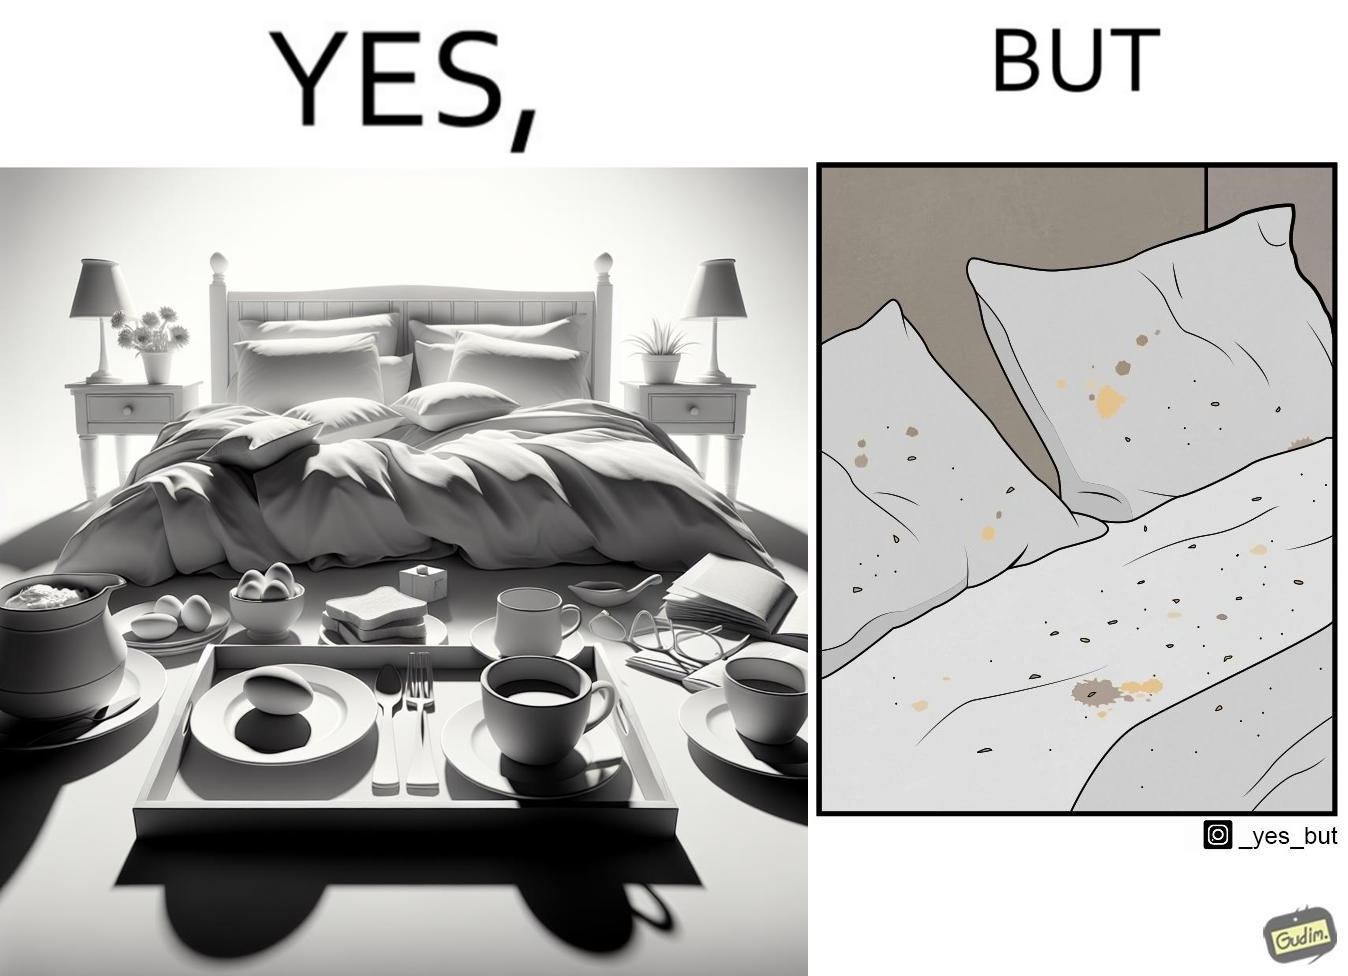Does this image contain satire or humor? Yes, this image is satirical. 